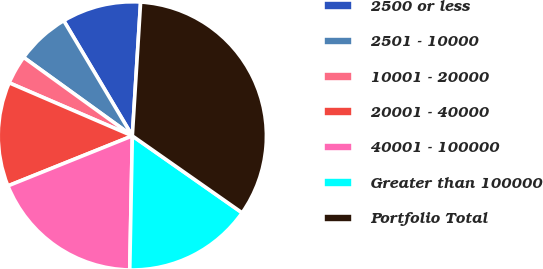Convert chart. <chart><loc_0><loc_0><loc_500><loc_500><pie_chart><fcel>2500 or less<fcel>2501 - 10000<fcel>10001 - 20000<fcel>20001 - 40000<fcel>40001 - 100000<fcel>Greater than 100000<fcel>Portfolio Total<nl><fcel>9.53%<fcel>6.5%<fcel>3.48%<fcel>12.56%<fcel>18.61%<fcel>15.58%<fcel>33.74%<nl></chart> 